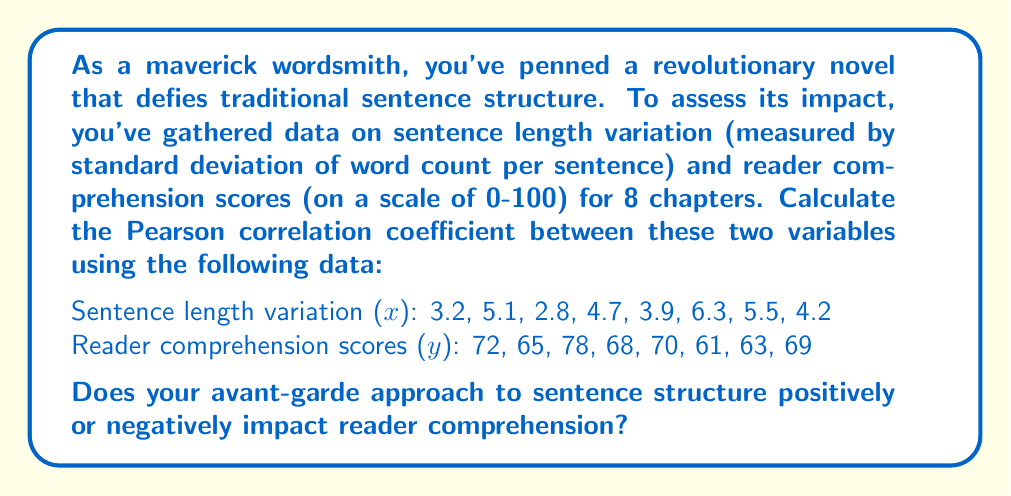What is the answer to this math problem? To calculate the Pearson correlation coefficient, we'll use the formula:

$$ r = \frac{n\sum xy - \sum x \sum y}{\sqrt{[n\sum x^2 - (\sum x)^2][n\sum y^2 - (\sum y)^2]}} $$

where $n$ is the number of data points.

Step 1: Calculate the sums and squared sums:
$n = 8$
$\sum x = 35.7$
$\sum y = 546$
$\sum xy = 2418.9$
$\sum x^2 = 164.95$
$\sum y^2 = 37,438$

Step 2: Calculate $(\sum x)^2$ and $(\sum y)^2$:
$(\sum x)^2 = 1274.49$
$(\sum y)^2 = 298,116$

Step 3: Apply the formula:

$$ r = \frac{8(2418.9) - 35.7(546)}{\sqrt{[8(164.95) - 1274.49][8(37,438) - 298,116]}} $$

$$ r = \frac{19351.2 - 19492.2}{\sqrt{(45.11)(1188)}} $$

$$ r = \frac{-141}{\sqrt{53590.68}} $$

$$ r = \frac{-141}{231.5} $$

$$ r \approx -0.609 $$

The Pearson correlation coefficient is approximately -0.609, indicating a moderate negative correlation between sentence length variation and reader comprehension scores.
Answer: $r \approx -0.609$

This negative correlation suggests that as sentence length variation increases, reader comprehension tends to decrease. Your avant-garde approach to sentence structure appears to negatively impact reader comprehension, though the relationship is moderate rather than strong. 